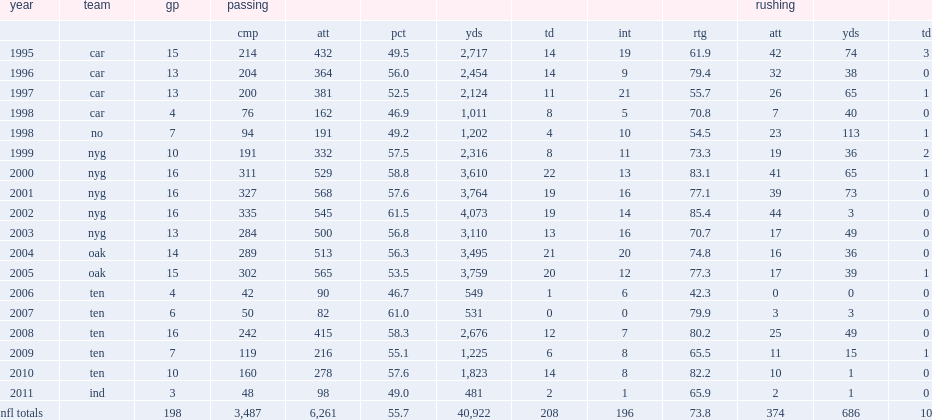In 2002, how many yards did collins set the passing record with? 4073.0. 